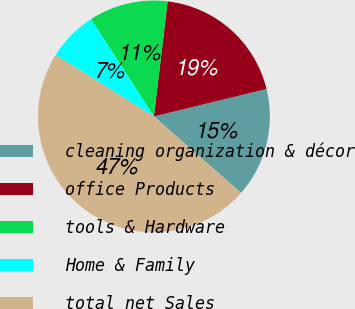Convert chart. <chart><loc_0><loc_0><loc_500><loc_500><pie_chart><fcel>cleaning organization & décor<fcel>office Products<fcel>tools & Hardware<fcel>Home & Family<fcel>total net Sales<nl><fcel>15.27%<fcel>19.31%<fcel>11.02%<fcel>6.97%<fcel>47.43%<nl></chart> 